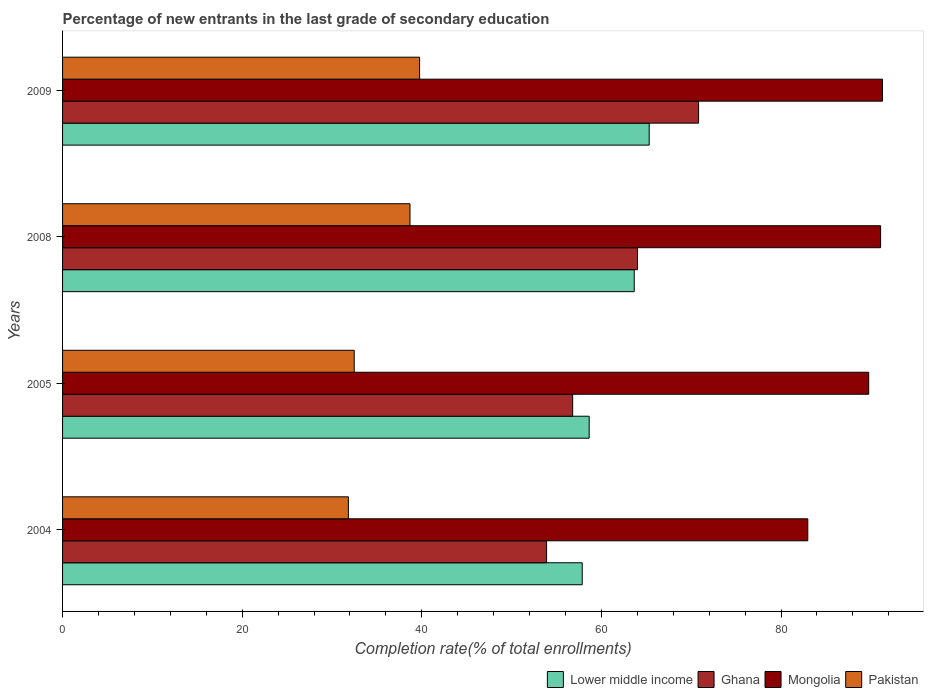How many bars are there on the 4th tick from the top?
Give a very brief answer. 4. What is the label of the 3rd group of bars from the top?
Your answer should be very brief. 2005. In how many cases, is the number of bars for a given year not equal to the number of legend labels?
Make the answer very short. 0. What is the percentage of new entrants in Lower middle income in 2009?
Ensure brevity in your answer.  65.32. Across all years, what is the maximum percentage of new entrants in Ghana?
Your response must be concise. 70.82. Across all years, what is the minimum percentage of new entrants in Pakistan?
Keep it short and to the point. 31.83. In which year was the percentage of new entrants in Lower middle income maximum?
Provide a succinct answer. 2009. In which year was the percentage of new entrants in Lower middle income minimum?
Your answer should be very brief. 2004. What is the total percentage of new entrants in Pakistan in the graph?
Ensure brevity in your answer.  142.75. What is the difference between the percentage of new entrants in Pakistan in 2004 and that in 2005?
Provide a short and direct response. -0.65. What is the difference between the percentage of new entrants in Ghana in 2004 and the percentage of new entrants in Mongolia in 2008?
Your answer should be compact. -37.19. What is the average percentage of new entrants in Mongolia per year?
Ensure brevity in your answer.  88.78. In the year 2004, what is the difference between the percentage of new entrants in Ghana and percentage of new entrants in Lower middle income?
Give a very brief answer. -3.97. What is the ratio of the percentage of new entrants in Mongolia in 2008 to that in 2009?
Make the answer very short. 1. Is the percentage of new entrants in Mongolia in 2004 less than that in 2008?
Give a very brief answer. Yes. What is the difference between the highest and the second highest percentage of new entrants in Lower middle income?
Your answer should be very brief. 1.67. What is the difference between the highest and the lowest percentage of new entrants in Lower middle income?
Keep it short and to the point. 7.46. In how many years, is the percentage of new entrants in Mongolia greater than the average percentage of new entrants in Mongolia taken over all years?
Ensure brevity in your answer.  3. Is it the case that in every year, the sum of the percentage of new entrants in Mongolia and percentage of new entrants in Lower middle income is greater than the sum of percentage of new entrants in Ghana and percentage of new entrants in Pakistan?
Provide a short and direct response. Yes. What does the 1st bar from the top in 2008 represents?
Make the answer very short. Pakistan. What does the 1st bar from the bottom in 2008 represents?
Your answer should be compact. Lower middle income. How many years are there in the graph?
Provide a short and direct response. 4. What is the difference between two consecutive major ticks on the X-axis?
Make the answer very short. 20. Does the graph contain grids?
Ensure brevity in your answer.  No. How are the legend labels stacked?
Ensure brevity in your answer.  Horizontal. What is the title of the graph?
Keep it short and to the point. Percentage of new entrants in the last grade of secondary education. Does "Mauritania" appear as one of the legend labels in the graph?
Your answer should be very brief. No. What is the label or title of the X-axis?
Your answer should be compact. Completion rate(% of total enrollments). What is the Completion rate(% of total enrollments) in Lower middle income in 2004?
Your answer should be very brief. 57.86. What is the Completion rate(% of total enrollments) in Ghana in 2004?
Your answer should be compact. 53.9. What is the Completion rate(% of total enrollments) of Mongolia in 2004?
Provide a succinct answer. 82.98. What is the Completion rate(% of total enrollments) of Pakistan in 2004?
Provide a short and direct response. 31.83. What is the Completion rate(% of total enrollments) in Lower middle income in 2005?
Keep it short and to the point. 58.64. What is the Completion rate(% of total enrollments) in Ghana in 2005?
Make the answer very short. 56.8. What is the Completion rate(% of total enrollments) in Mongolia in 2005?
Offer a terse response. 89.76. What is the Completion rate(% of total enrollments) in Pakistan in 2005?
Offer a very short reply. 32.48. What is the Completion rate(% of total enrollments) in Lower middle income in 2008?
Keep it short and to the point. 63.65. What is the Completion rate(% of total enrollments) of Ghana in 2008?
Ensure brevity in your answer.  64.02. What is the Completion rate(% of total enrollments) of Mongolia in 2008?
Make the answer very short. 91.09. What is the Completion rate(% of total enrollments) in Pakistan in 2008?
Your answer should be very brief. 38.69. What is the Completion rate(% of total enrollments) of Lower middle income in 2009?
Provide a short and direct response. 65.32. What is the Completion rate(% of total enrollments) in Ghana in 2009?
Your response must be concise. 70.82. What is the Completion rate(% of total enrollments) in Mongolia in 2009?
Your response must be concise. 91.3. What is the Completion rate(% of total enrollments) in Pakistan in 2009?
Your answer should be very brief. 39.76. Across all years, what is the maximum Completion rate(% of total enrollments) in Lower middle income?
Give a very brief answer. 65.32. Across all years, what is the maximum Completion rate(% of total enrollments) of Ghana?
Provide a succinct answer. 70.82. Across all years, what is the maximum Completion rate(% of total enrollments) of Mongolia?
Make the answer very short. 91.3. Across all years, what is the maximum Completion rate(% of total enrollments) in Pakistan?
Provide a succinct answer. 39.76. Across all years, what is the minimum Completion rate(% of total enrollments) of Lower middle income?
Your answer should be very brief. 57.86. Across all years, what is the minimum Completion rate(% of total enrollments) in Ghana?
Make the answer very short. 53.9. Across all years, what is the minimum Completion rate(% of total enrollments) of Mongolia?
Ensure brevity in your answer.  82.98. Across all years, what is the minimum Completion rate(% of total enrollments) in Pakistan?
Make the answer very short. 31.83. What is the total Completion rate(% of total enrollments) of Lower middle income in the graph?
Ensure brevity in your answer.  245.48. What is the total Completion rate(% of total enrollments) of Ghana in the graph?
Provide a short and direct response. 245.54. What is the total Completion rate(% of total enrollments) of Mongolia in the graph?
Your answer should be compact. 355.14. What is the total Completion rate(% of total enrollments) in Pakistan in the graph?
Keep it short and to the point. 142.75. What is the difference between the Completion rate(% of total enrollments) in Lower middle income in 2004 and that in 2005?
Make the answer very short. -0.77. What is the difference between the Completion rate(% of total enrollments) in Ghana in 2004 and that in 2005?
Keep it short and to the point. -2.9. What is the difference between the Completion rate(% of total enrollments) in Mongolia in 2004 and that in 2005?
Ensure brevity in your answer.  -6.78. What is the difference between the Completion rate(% of total enrollments) of Pakistan in 2004 and that in 2005?
Your response must be concise. -0.65. What is the difference between the Completion rate(% of total enrollments) in Lower middle income in 2004 and that in 2008?
Ensure brevity in your answer.  -5.79. What is the difference between the Completion rate(% of total enrollments) in Ghana in 2004 and that in 2008?
Keep it short and to the point. -10.12. What is the difference between the Completion rate(% of total enrollments) of Mongolia in 2004 and that in 2008?
Your answer should be very brief. -8.11. What is the difference between the Completion rate(% of total enrollments) in Pakistan in 2004 and that in 2008?
Provide a succinct answer. -6.86. What is the difference between the Completion rate(% of total enrollments) of Lower middle income in 2004 and that in 2009?
Give a very brief answer. -7.46. What is the difference between the Completion rate(% of total enrollments) of Ghana in 2004 and that in 2009?
Keep it short and to the point. -16.92. What is the difference between the Completion rate(% of total enrollments) of Mongolia in 2004 and that in 2009?
Provide a succinct answer. -8.32. What is the difference between the Completion rate(% of total enrollments) of Pakistan in 2004 and that in 2009?
Offer a terse response. -7.93. What is the difference between the Completion rate(% of total enrollments) of Lower middle income in 2005 and that in 2008?
Your answer should be very brief. -5.01. What is the difference between the Completion rate(% of total enrollments) of Ghana in 2005 and that in 2008?
Your response must be concise. -7.22. What is the difference between the Completion rate(% of total enrollments) of Mongolia in 2005 and that in 2008?
Make the answer very short. -1.33. What is the difference between the Completion rate(% of total enrollments) of Pakistan in 2005 and that in 2008?
Offer a very short reply. -6.21. What is the difference between the Completion rate(% of total enrollments) of Lower middle income in 2005 and that in 2009?
Provide a succinct answer. -6.68. What is the difference between the Completion rate(% of total enrollments) of Ghana in 2005 and that in 2009?
Ensure brevity in your answer.  -14.02. What is the difference between the Completion rate(% of total enrollments) in Mongolia in 2005 and that in 2009?
Give a very brief answer. -1.54. What is the difference between the Completion rate(% of total enrollments) in Pakistan in 2005 and that in 2009?
Keep it short and to the point. -7.28. What is the difference between the Completion rate(% of total enrollments) in Lower middle income in 2008 and that in 2009?
Make the answer very short. -1.67. What is the difference between the Completion rate(% of total enrollments) in Ghana in 2008 and that in 2009?
Your response must be concise. -6.8. What is the difference between the Completion rate(% of total enrollments) in Mongolia in 2008 and that in 2009?
Ensure brevity in your answer.  -0.21. What is the difference between the Completion rate(% of total enrollments) of Pakistan in 2008 and that in 2009?
Your answer should be very brief. -1.07. What is the difference between the Completion rate(% of total enrollments) of Lower middle income in 2004 and the Completion rate(% of total enrollments) of Ghana in 2005?
Your answer should be very brief. 1.06. What is the difference between the Completion rate(% of total enrollments) in Lower middle income in 2004 and the Completion rate(% of total enrollments) in Mongolia in 2005?
Provide a short and direct response. -31.9. What is the difference between the Completion rate(% of total enrollments) of Lower middle income in 2004 and the Completion rate(% of total enrollments) of Pakistan in 2005?
Give a very brief answer. 25.39. What is the difference between the Completion rate(% of total enrollments) of Ghana in 2004 and the Completion rate(% of total enrollments) of Mongolia in 2005?
Your answer should be very brief. -35.87. What is the difference between the Completion rate(% of total enrollments) of Ghana in 2004 and the Completion rate(% of total enrollments) of Pakistan in 2005?
Provide a succinct answer. 21.42. What is the difference between the Completion rate(% of total enrollments) of Mongolia in 2004 and the Completion rate(% of total enrollments) of Pakistan in 2005?
Offer a very short reply. 50.51. What is the difference between the Completion rate(% of total enrollments) of Lower middle income in 2004 and the Completion rate(% of total enrollments) of Ghana in 2008?
Keep it short and to the point. -6.16. What is the difference between the Completion rate(% of total enrollments) of Lower middle income in 2004 and the Completion rate(% of total enrollments) of Mongolia in 2008?
Your answer should be very brief. -33.23. What is the difference between the Completion rate(% of total enrollments) in Lower middle income in 2004 and the Completion rate(% of total enrollments) in Pakistan in 2008?
Your answer should be very brief. 19.18. What is the difference between the Completion rate(% of total enrollments) of Ghana in 2004 and the Completion rate(% of total enrollments) of Mongolia in 2008?
Your answer should be compact. -37.19. What is the difference between the Completion rate(% of total enrollments) of Ghana in 2004 and the Completion rate(% of total enrollments) of Pakistan in 2008?
Your answer should be compact. 15.21. What is the difference between the Completion rate(% of total enrollments) of Mongolia in 2004 and the Completion rate(% of total enrollments) of Pakistan in 2008?
Offer a terse response. 44.29. What is the difference between the Completion rate(% of total enrollments) in Lower middle income in 2004 and the Completion rate(% of total enrollments) in Ghana in 2009?
Ensure brevity in your answer.  -12.96. What is the difference between the Completion rate(% of total enrollments) of Lower middle income in 2004 and the Completion rate(% of total enrollments) of Mongolia in 2009?
Provide a short and direct response. -33.44. What is the difference between the Completion rate(% of total enrollments) of Lower middle income in 2004 and the Completion rate(% of total enrollments) of Pakistan in 2009?
Your answer should be compact. 18.11. What is the difference between the Completion rate(% of total enrollments) of Ghana in 2004 and the Completion rate(% of total enrollments) of Mongolia in 2009?
Your answer should be compact. -37.4. What is the difference between the Completion rate(% of total enrollments) in Ghana in 2004 and the Completion rate(% of total enrollments) in Pakistan in 2009?
Your answer should be very brief. 14.14. What is the difference between the Completion rate(% of total enrollments) of Mongolia in 2004 and the Completion rate(% of total enrollments) of Pakistan in 2009?
Ensure brevity in your answer.  43.23. What is the difference between the Completion rate(% of total enrollments) of Lower middle income in 2005 and the Completion rate(% of total enrollments) of Ghana in 2008?
Offer a very short reply. -5.38. What is the difference between the Completion rate(% of total enrollments) of Lower middle income in 2005 and the Completion rate(% of total enrollments) of Mongolia in 2008?
Your answer should be very brief. -32.45. What is the difference between the Completion rate(% of total enrollments) of Lower middle income in 2005 and the Completion rate(% of total enrollments) of Pakistan in 2008?
Your answer should be very brief. 19.95. What is the difference between the Completion rate(% of total enrollments) in Ghana in 2005 and the Completion rate(% of total enrollments) in Mongolia in 2008?
Give a very brief answer. -34.29. What is the difference between the Completion rate(% of total enrollments) of Ghana in 2005 and the Completion rate(% of total enrollments) of Pakistan in 2008?
Offer a very short reply. 18.11. What is the difference between the Completion rate(% of total enrollments) of Mongolia in 2005 and the Completion rate(% of total enrollments) of Pakistan in 2008?
Provide a short and direct response. 51.08. What is the difference between the Completion rate(% of total enrollments) of Lower middle income in 2005 and the Completion rate(% of total enrollments) of Ghana in 2009?
Provide a succinct answer. -12.18. What is the difference between the Completion rate(% of total enrollments) of Lower middle income in 2005 and the Completion rate(% of total enrollments) of Mongolia in 2009?
Your response must be concise. -32.66. What is the difference between the Completion rate(% of total enrollments) in Lower middle income in 2005 and the Completion rate(% of total enrollments) in Pakistan in 2009?
Keep it short and to the point. 18.88. What is the difference between the Completion rate(% of total enrollments) of Ghana in 2005 and the Completion rate(% of total enrollments) of Mongolia in 2009?
Offer a terse response. -34.5. What is the difference between the Completion rate(% of total enrollments) of Ghana in 2005 and the Completion rate(% of total enrollments) of Pakistan in 2009?
Provide a succinct answer. 17.04. What is the difference between the Completion rate(% of total enrollments) in Mongolia in 2005 and the Completion rate(% of total enrollments) in Pakistan in 2009?
Your answer should be compact. 50.01. What is the difference between the Completion rate(% of total enrollments) in Lower middle income in 2008 and the Completion rate(% of total enrollments) in Ghana in 2009?
Keep it short and to the point. -7.17. What is the difference between the Completion rate(% of total enrollments) in Lower middle income in 2008 and the Completion rate(% of total enrollments) in Mongolia in 2009?
Your answer should be compact. -27.65. What is the difference between the Completion rate(% of total enrollments) of Lower middle income in 2008 and the Completion rate(% of total enrollments) of Pakistan in 2009?
Give a very brief answer. 23.9. What is the difference between the Completion rate(% of total enrollments) of Ghana in 2008 and the Completion rate(% of total enrollments) of Mongolia in 2009?
Your answer should be compact. -27.28. What is the difference between the Completion rate(% of total enrollments) in Ghana in 2008 and the Completion rate(% of total enrollments) in Pakistan in 2009?
Make the answer very short. 24.26. What is the difference between the Completion rate(% of total enrollments) in Mongolia in 2008 and the Completion rate(% of total enrollments) in Pakistan in 2009?
Offer a very short reply. 51.33. What is the average Completion rate(% of total enrollments) in Lower middle income per year?
Your response must be concise. 61.37. What is the average Completion rate(% of total enrollments) of Ghana per year?
Offer a very short reply. 61.38. What is the average Completion rate(% of total enrollments) of Mongolia per year?
Provide a short and direct response. 88.78. What is the average Completion rate(% of total enrollments) in Pakistan per year?
Offer a terse response. 35.69. In the year 2004, what is the difference between the Completion rate(% of total enrollments) in Lower middle income and Completion rate(% of total enrollments) in Ghana?
Keep it short and to the point. 3.97. In the year 2004, what is the difference between the Completion rate(% of total enrollments) in Lower middle income and Completion rate(% of total enrollments) in Mongolia?
Your response must be concise. -25.12. In the year 2004, what is the difference between the Completion rate(% of total enrollments) in Lower middle income and Completion rate(% of total enrollments) in Pakistan?
Offer a terse response. 26.04. In the year 2004, what is the difference between the Completion rate(% of total enrollments) in Ghana and Completion rate(% of total enrollments) in Mongolia?
Keep it short and to the point. -29.09. In the year 2004, what is the difference between the Completion rate(% of total enrollments) of Ghana and Completion rate(% of total enrollments) of Pakistan?
Your answer should be very brief. 22.07. In the year 2004, what is the difference between the Completion rate(% of total enrollments) in Mongolia and Completion rate(% of total enrollments) in Pakistan?
Make the answer very short. 51.16. In the year 2005, what is the difference between the Completion rate(% of total enrollments) of Lower middle income and Completion rate(% of total enrollments) of Ghana?
Your answer should be compact. 1.84. In the year 2005, what is the difference between the Completion rate(% of total enrollments) in Lower middle income and Completion rate(% of total enrollments) in Mongolia?
Your answer should be very brief. -31.13. In the year 2005, what is the difference between the Completion rate(% of total enrollments) in Lower middle income and Completion rate(% of total enrollments) in Pakistan?
Give a very brief answer. 26.16. In the year 2005, what is the difference between the Completion rate(% of total enrollments) of Ghana and Completion rate(% of total enrollments) of Mongolia?
Your answer should be compact. -32.96. In the year 2005, what is the difference between the Completion rate(% of total enrollments) in Ghana and Completion rate(% of total enrollments) in Pakistan?
Make the answer very short. 24.33. In the year 2005, what is the difference between the Completion rate(% of total enrollments) of Mongolia and Completion rate(% of total enrollments) of Pakistan?
Ensure brevity in your answer.  57.29. In the year 2008, what is the difference between the Completion rate(% of total enrollments) of Lower middle income and Completion rate(% of total enrollments) of Ghana?
Your answer should be compact. -0.37. In the year 2008, what is the difference between the Completion rate(% of total enrollments) of Lower middle income and Completion rate(% of total enrollments) of Mongolia?
Give a very brief answer. -27.44. In the year 2008, what is the difference between the Completion rate(% of total enrollments) in Lower middle income and Completion rate(% of total enrollments) in Pakistan?
Give a very brief answer. 24.97. In the year 2008, what is the difference between the Completion rate(% of total enrollments) in Ghana and Completion rate(% of total enrollments) in Mongolia?
Offer a very short reply. -27.07. In the year 2008, what is the difference between the Completion rate(% of total enrollments) of Ghana and Completion rate(% of total enrollments) of Pakistan?
Your answer should be very brief. 25.33. In the year 2008, what is the difference between the Completion rate(% of total enrollments) in Mongolia and Completion rate(% of total enrollments) in Pakistan?
Give a very brief answer. 52.4. In the year 2009, what is the difference between the Completion rate(% of total enrollments) in Lower middle income and Completion rate(% of total enrollments) in Ghana?
Ensure brevity in your answer.  -5.5. In the year 2009, what is the difference between the Completion rate(% of total enrollments) in Lower middle income and Completion rate(% of total enrollments) in Mongolia?
Make the answer very short. -25.98. In the year 2009, what is the difference between the Completion rate(% of total enrollments) of Lower middle income and Completion rate(% of total enrollments) of Pakistan?
Your answer should be compact. 25.56. In the year 2009, what is the difference between the Completion rate(% of total enrollments) of Ghana and Completion rate(% of total enrollments) of Mongolia?
Offer a terse response. -20.48. In the year 2009, what is the difference between the Completion rate(% of total enrollments) in Ghana and Completion rate(% of total enrollments) in Pakistan?
Your response must be concise. 31.06. In the year 2009, what is the difference between the Completion rate(% of total enrollments) of Mongolia and Completion rate(% of total enrollments) of Pakistan?
Give a very brief answer. 51.54. What is the ratio of the Completion rate(% of total enrollments) in Lower middle income in 2004 to that in 2005?
Give a very brief answer. 0.99. What is the ratio of the Completion rate(% of total enrollments) of Ghana in 2004 to that in 2005?
Provide a succinct answer. 0.95. What is the ratio of the Completion rate(% of total enrollments) in Mongolia in 2004 to that in 2005?
Your response must be concise. 0.92. What is the ratio of the Completion rate(% of total enrollments) of Pakistan in 2004 to that in 2005?
Your answer should be very brief. 0.98. What is the ratio of the Completion rate(% of total enrollments) of Lower middle income in 2004 to that in 2008?
Offer a very short reply. 0.91. What is the ratio of the Completion rate(% of total enrollments) in Ghana in 2004 to that in 2008?
Give a very brief answer. 0.84. What is the ratio of the Completion rate(% of total enrollments) of Mongolia in 2004 to that in 2008?
Make the answer very short. 0.91. What is the ratio of the Completion rate(% of total enrollments) in Pakistan in 2004 to that in 2008?
Your answer should be very brief. 0.82. What is the ratio of the Completion rate(% of total enrollments) of Lower middle income in 2004 to that in 2009?
Ensure brevity in your answer.  0.89. What is the ratio of the Completion rate(% of total enrollments) in Ghana in 2004 to that in 2009?
Ensure brevity in your answer.  0.76. What is the ratio of the Completion rate(% of total enrollments) in Mongolia in 2004 to that in 2009?
Provide a short and direct response. 0.91. What is the ratio of the Completion rate(% of total enrollments) of Pakistan in 2004 to that in 2009?
Offer a very short reply. 0.8. What is the ratio of the Completion rate(% of total enrollments) of Lower middle income in 2005 to that in 2008?
Offer a terse response. 0.92. What is the ratio of the Completion rate(% of total enrollments) in Ghana in 2005 to that in 2008?
Your answer should be very brief. 0.89. What is the ratio of the Completion rate(% of total enrollments) in Mongolia in 2005 to that in 2008?
Provide a succinct answer. 0.99. What is the ratio of the Completion rate(% of total enrollments) in Pakistan in 2005 to that in 2008?
Provide a succinct answer. 0.84. What is the ratio of the Completion rate(% of total enrollments) in Lower middle income in 2005 to that in 2009?
Offer a very short reply. 0.9. What is the ratio of the Completion rate(% of total enrollments) of Ghana in 2005 to that in 2009?
Give a very brief answer. 0.8. What is the ratio of the Completion rate(% of total enrollments) of Mongolia in 2005 to that in 2009?
Your answer should be very brief. 0.98. What is the ratio of the Completion rate(% of total enrollments) of Pakistan in 2005 to that in 2009?
Provide a succinct answer. 0.82. What is the ratio of the Completion rate(% of total enrollments) in Lower middle income in 2008 to that in 2009?
Make the answer very short. 0.97. What is the ratio of the Completion rate(% of total enrollments) of Ghana in 2008 to that in 2009?
Make the answer very short. 0.9. What is the ratio of the Completion rate(% of total enrollments) in Mongolia in 2008 to that in 2009?
Your answer should be very brief. 1. What is the ratio of the Completion rate(% of total enrollments) in Pakistan in 2008 to that in 2009?
Provide a succinct answer. 0.97. What is the difference between the highest and the second highest Completion rate(% of total enrollments) of Lower middle income?
Your response must be concise. 1.67. What is the difference between the highest and the second highest Completion rate(% of total enrollments) of Ghana?
Provide a succinct answer. 6.8. What is the difference between the highest and the second highest Completion rate(% of total enrollments) in Mongolia?
Keep it short and to the point. 0.21. What is the difference between the highest and the second highest Completion rate(% of total enrollments) of Pakistan?
Make the answer very short. 1.07. What is the difference between the highest and the lowest Completion rate(% of total enrollments) in Lower middle income?
Offer a terse response. 7.46. What is the difference between the highest and the lowest Completion rate(% of total enrollments) of Ghana?
Make the answer very short. 16.92. What is the difference between the highest and the lowest Completion rate(% of total enrollments) in Mongolia?
Your answer should be very brief. 8.32. What is the difference between the highest and the lowest Completion rate(% of total enrollments) in Pakistan?
Provide a succinct answer. 7.93. 